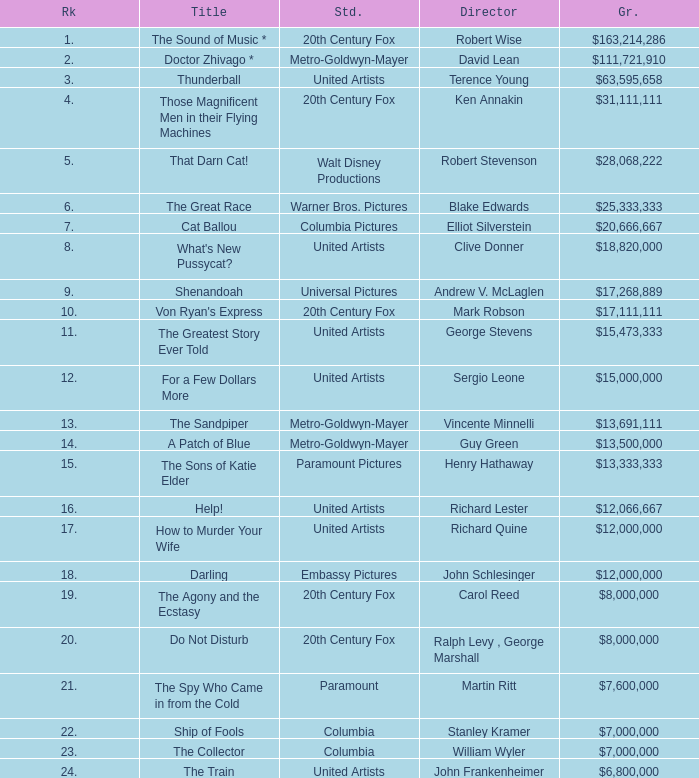What is Studio, when Title is "Do Not Disturb"? 20th Century Fox. 